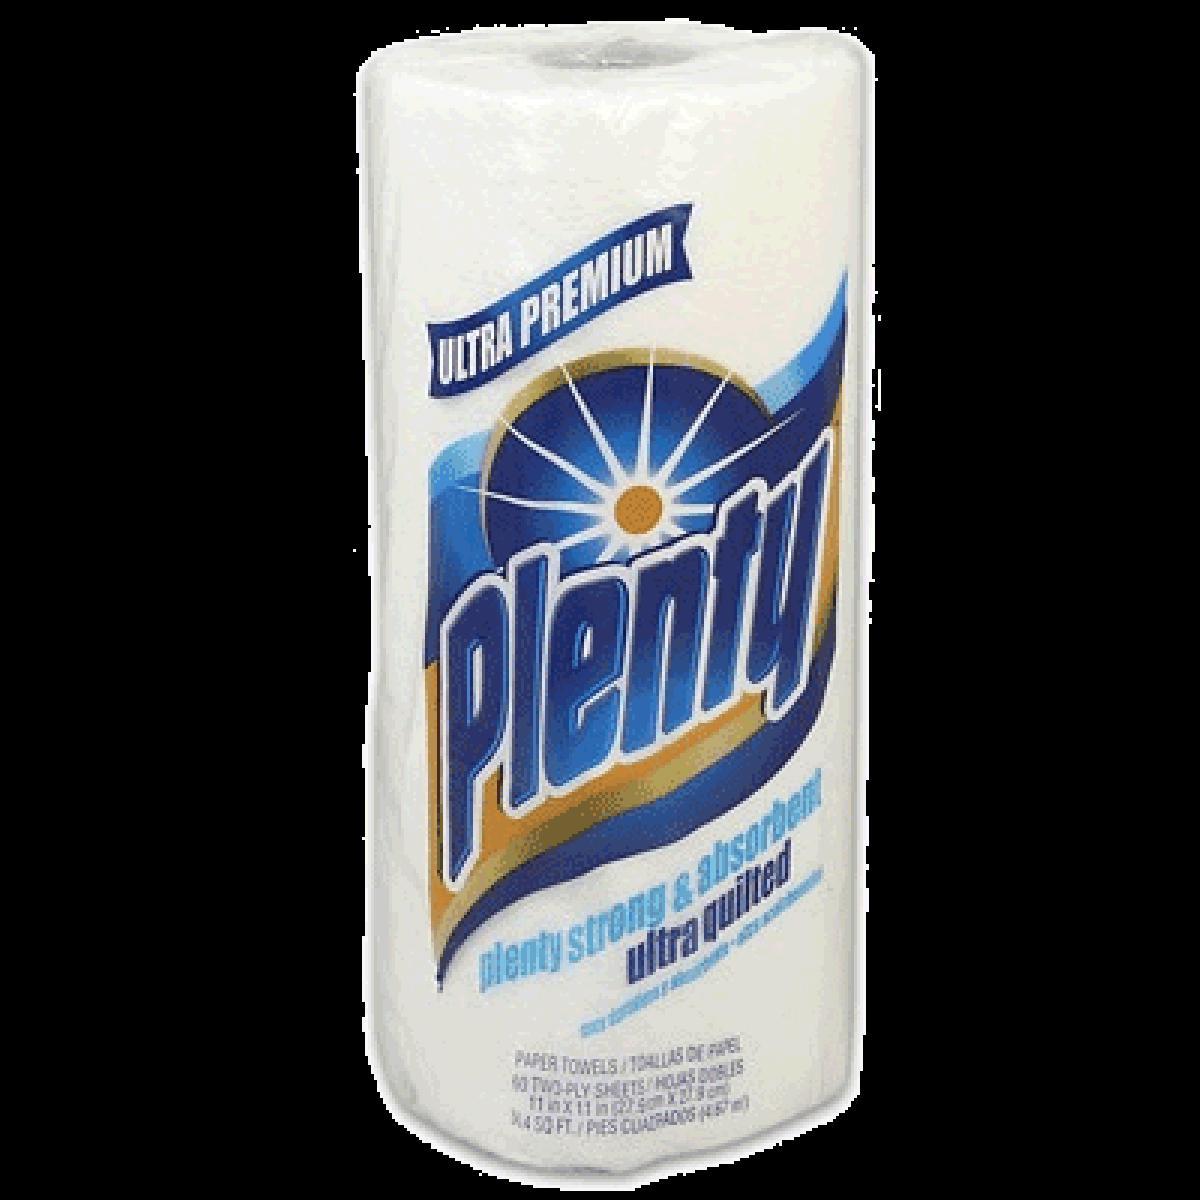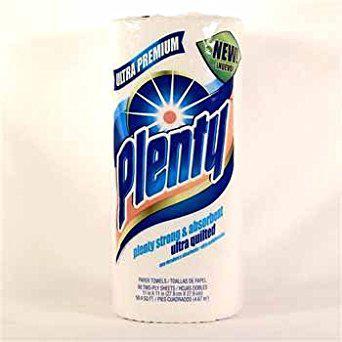The first image is the image on the left, the second image is the image on the right. Considering the images on both sides, is "Two individually wrapped rolls of paper towels are both standing upright and have similar brand labels, but are shown with different background colors." valid? Answer yes or no. Yes. The first image is the image on the left, the second image is the image on the right. Examine the images to the left and right. Is the description "Each image shows an individually-wrapped single roll of paper towels, and left and right packages have the same sunburst logo on front." accurate? Answer yes or no. Yes. 